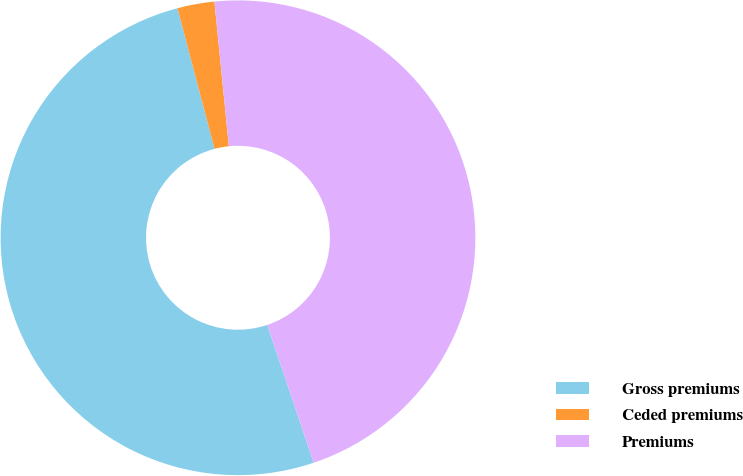Convert chart. <chart><loc_0><loc_0><loc_500><loc_500><pie_chart><fcel>Gross premiums<fcel>Ceded premiums<fcel>Premiums<nl><fcel>51.06%<fcel>2.52%<fcel>46.42%<nl></chart> 